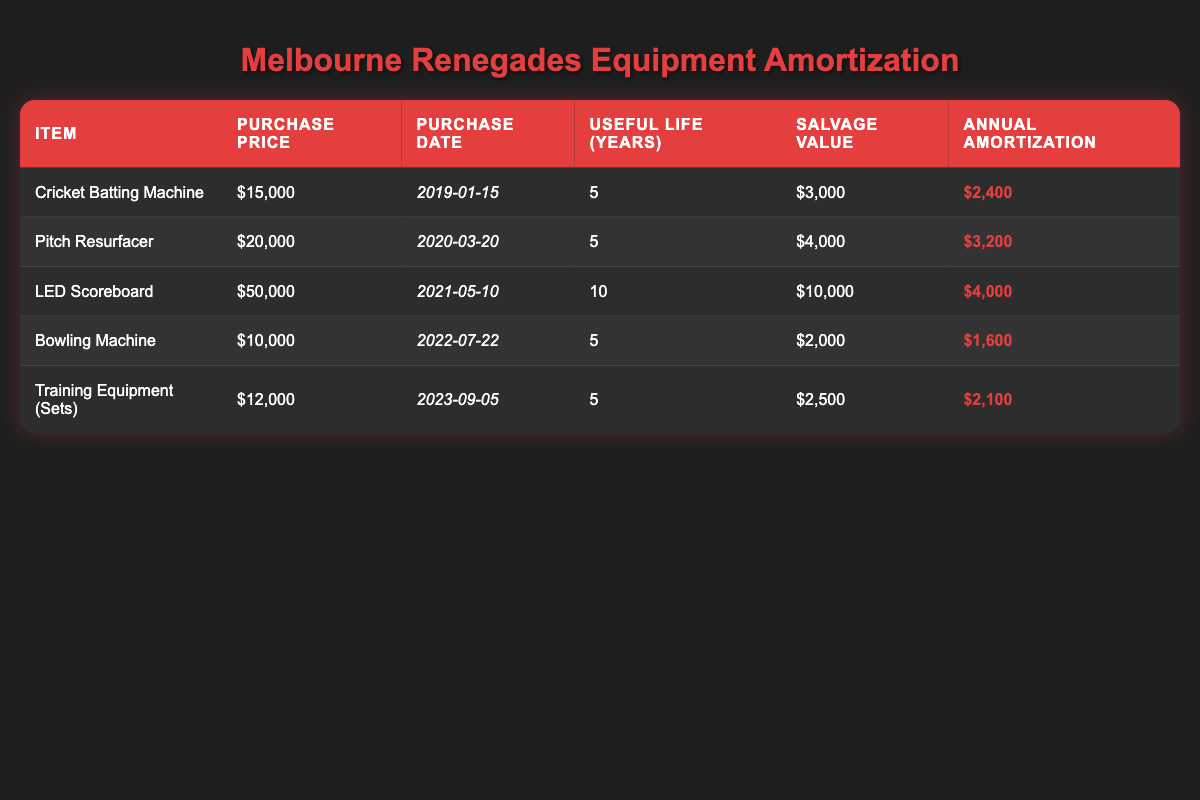What is the total annual amortization for the Cricket Batting Machine and the Bowling Machine? The annual amortization for the Cricket Batting Machine is 2,400 and for the Bowling Machine, it is 1,600. By adding these amounts, we have 2,400 + 1,600 = 4,000, which is the total annual amortization for both items.
Answer: 4,000 How much did the Melbourne Renegades spend on the Pitch Resurfacer? The purchase price of the Pitch Resurfacer is listed as 20,000 in the table.
Answer: 20,000 Is the salvage value of the LED Scoreboard greater than that of the Training Equipment (Sets)? The salvage value for the LED Scoreboard is 10,000 and for the Training Equipment (Sets) it is 2,500. Since 10,000 is greater than 2,500, the statement is true.
Answer: Yes What is the average annual amortization of all equipment items listed? To find the average, we first add together the annual amortization amounts: 2,400 + 3,200 + 4,000 + 1,600 + 2,100 = 13,300. There are 5 items, so the average is 13,300 divided by 5, which equals 2,660.
Answer: 2,660 Which equipment has the longest useful life, and what is that duration? The LED Scoreboard has the longest useful life of 10 years, compared to the other equipment items which have either 5 years or shorter.
Answer: LED Scoreboard, 10 years 